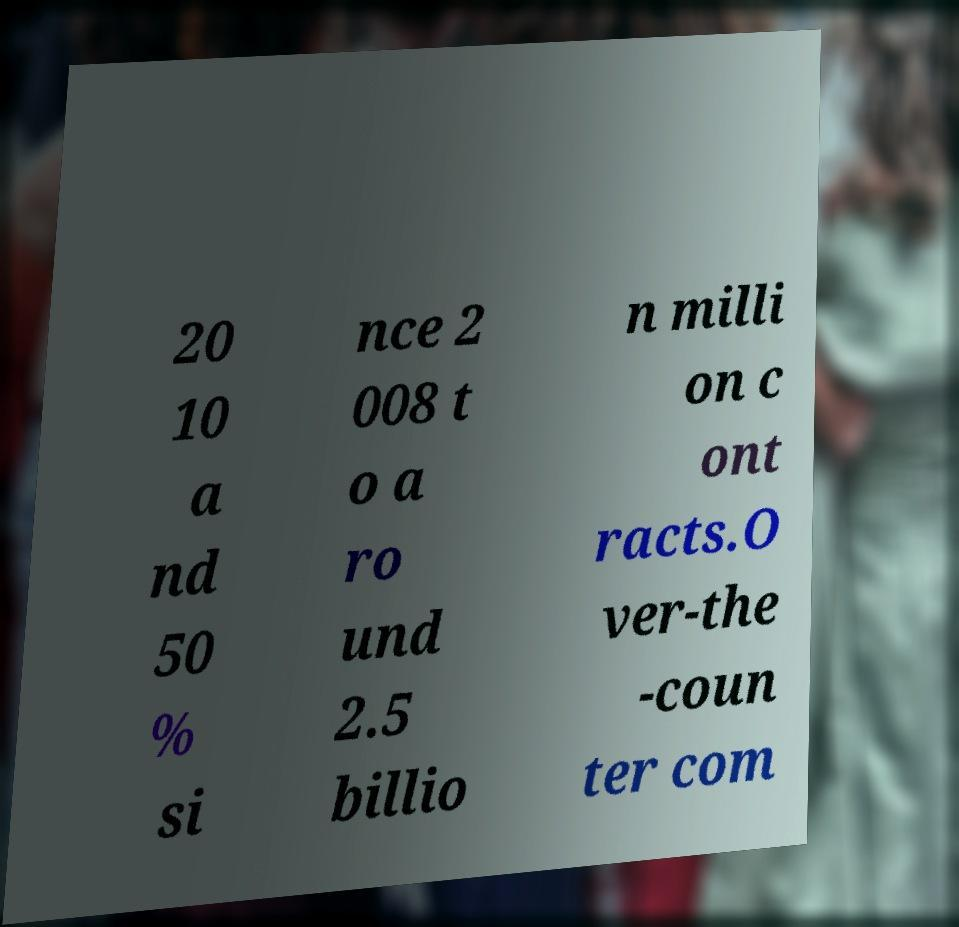There's text embedded in this image that I need extracted. Can you transcribe it verbatim? 20 10 a nd 50 % si nce 2 008 t o a ro und 2.5 billio n milli on c ont racts.O ver-the -coun ter com 